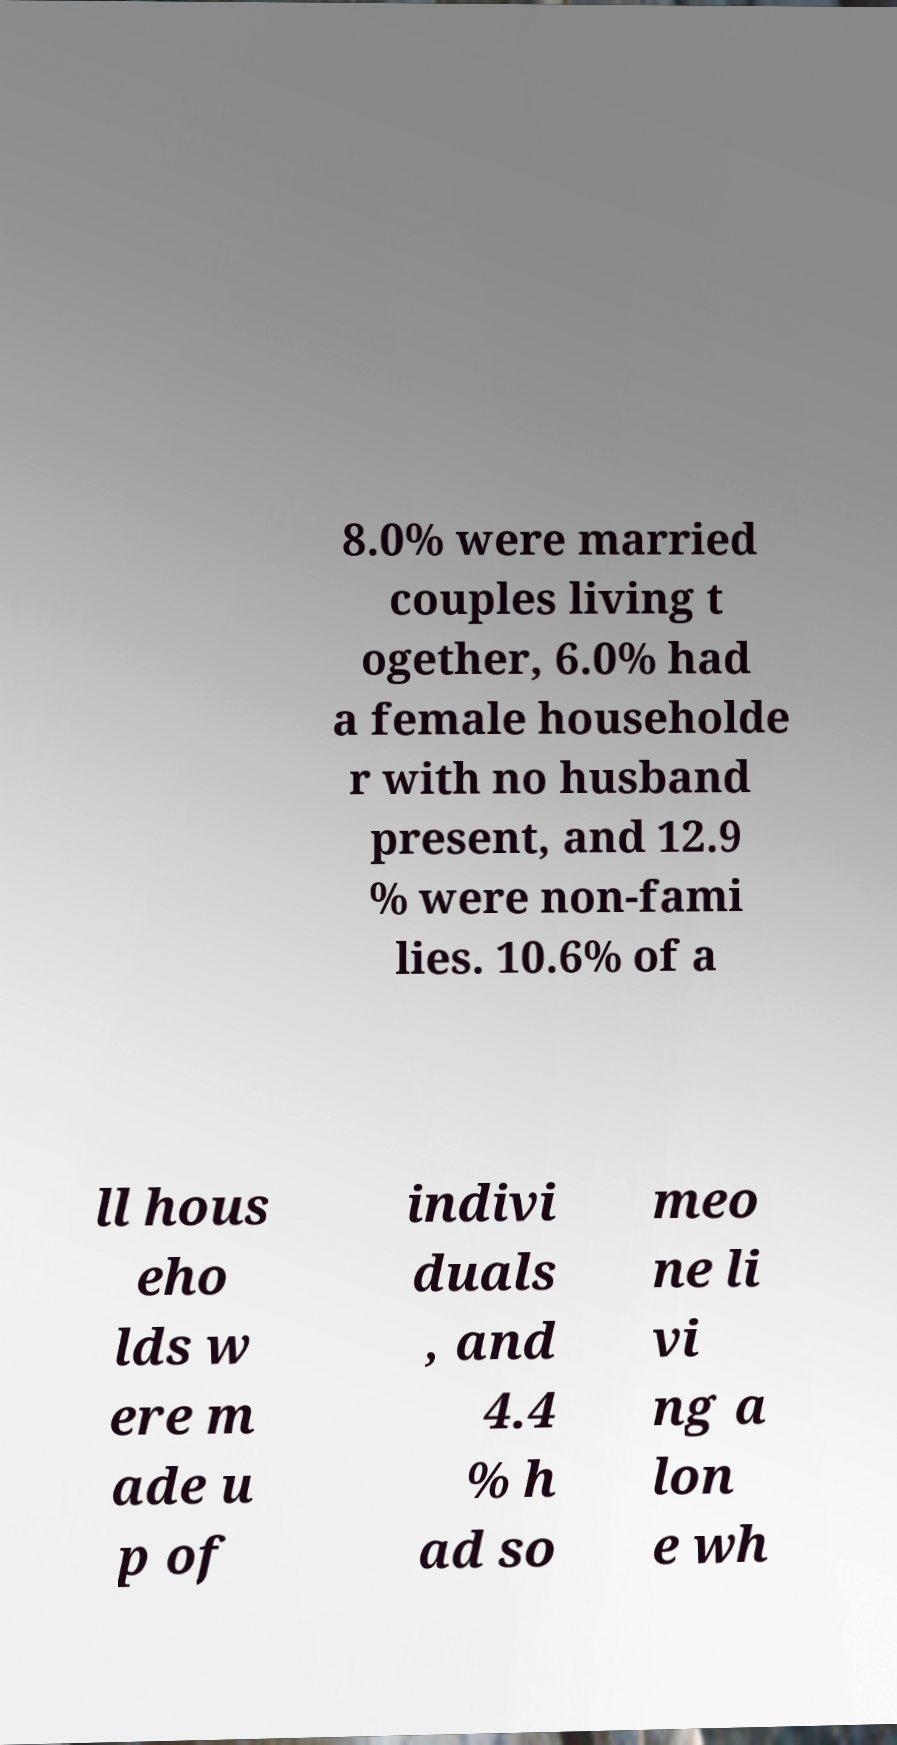For documentation purposes, I need the text within this image transcribed. Could you provide that? 8.0% were married couples living t ogether, 6.0% had a female householde r with no husband present, and 12.9 % were non-fami lies. 10.6% of a ll hous eho lds w ere m ade u p of indivi duals , and 4.4 % h ad so meo ne li vi ng a lon e wh 